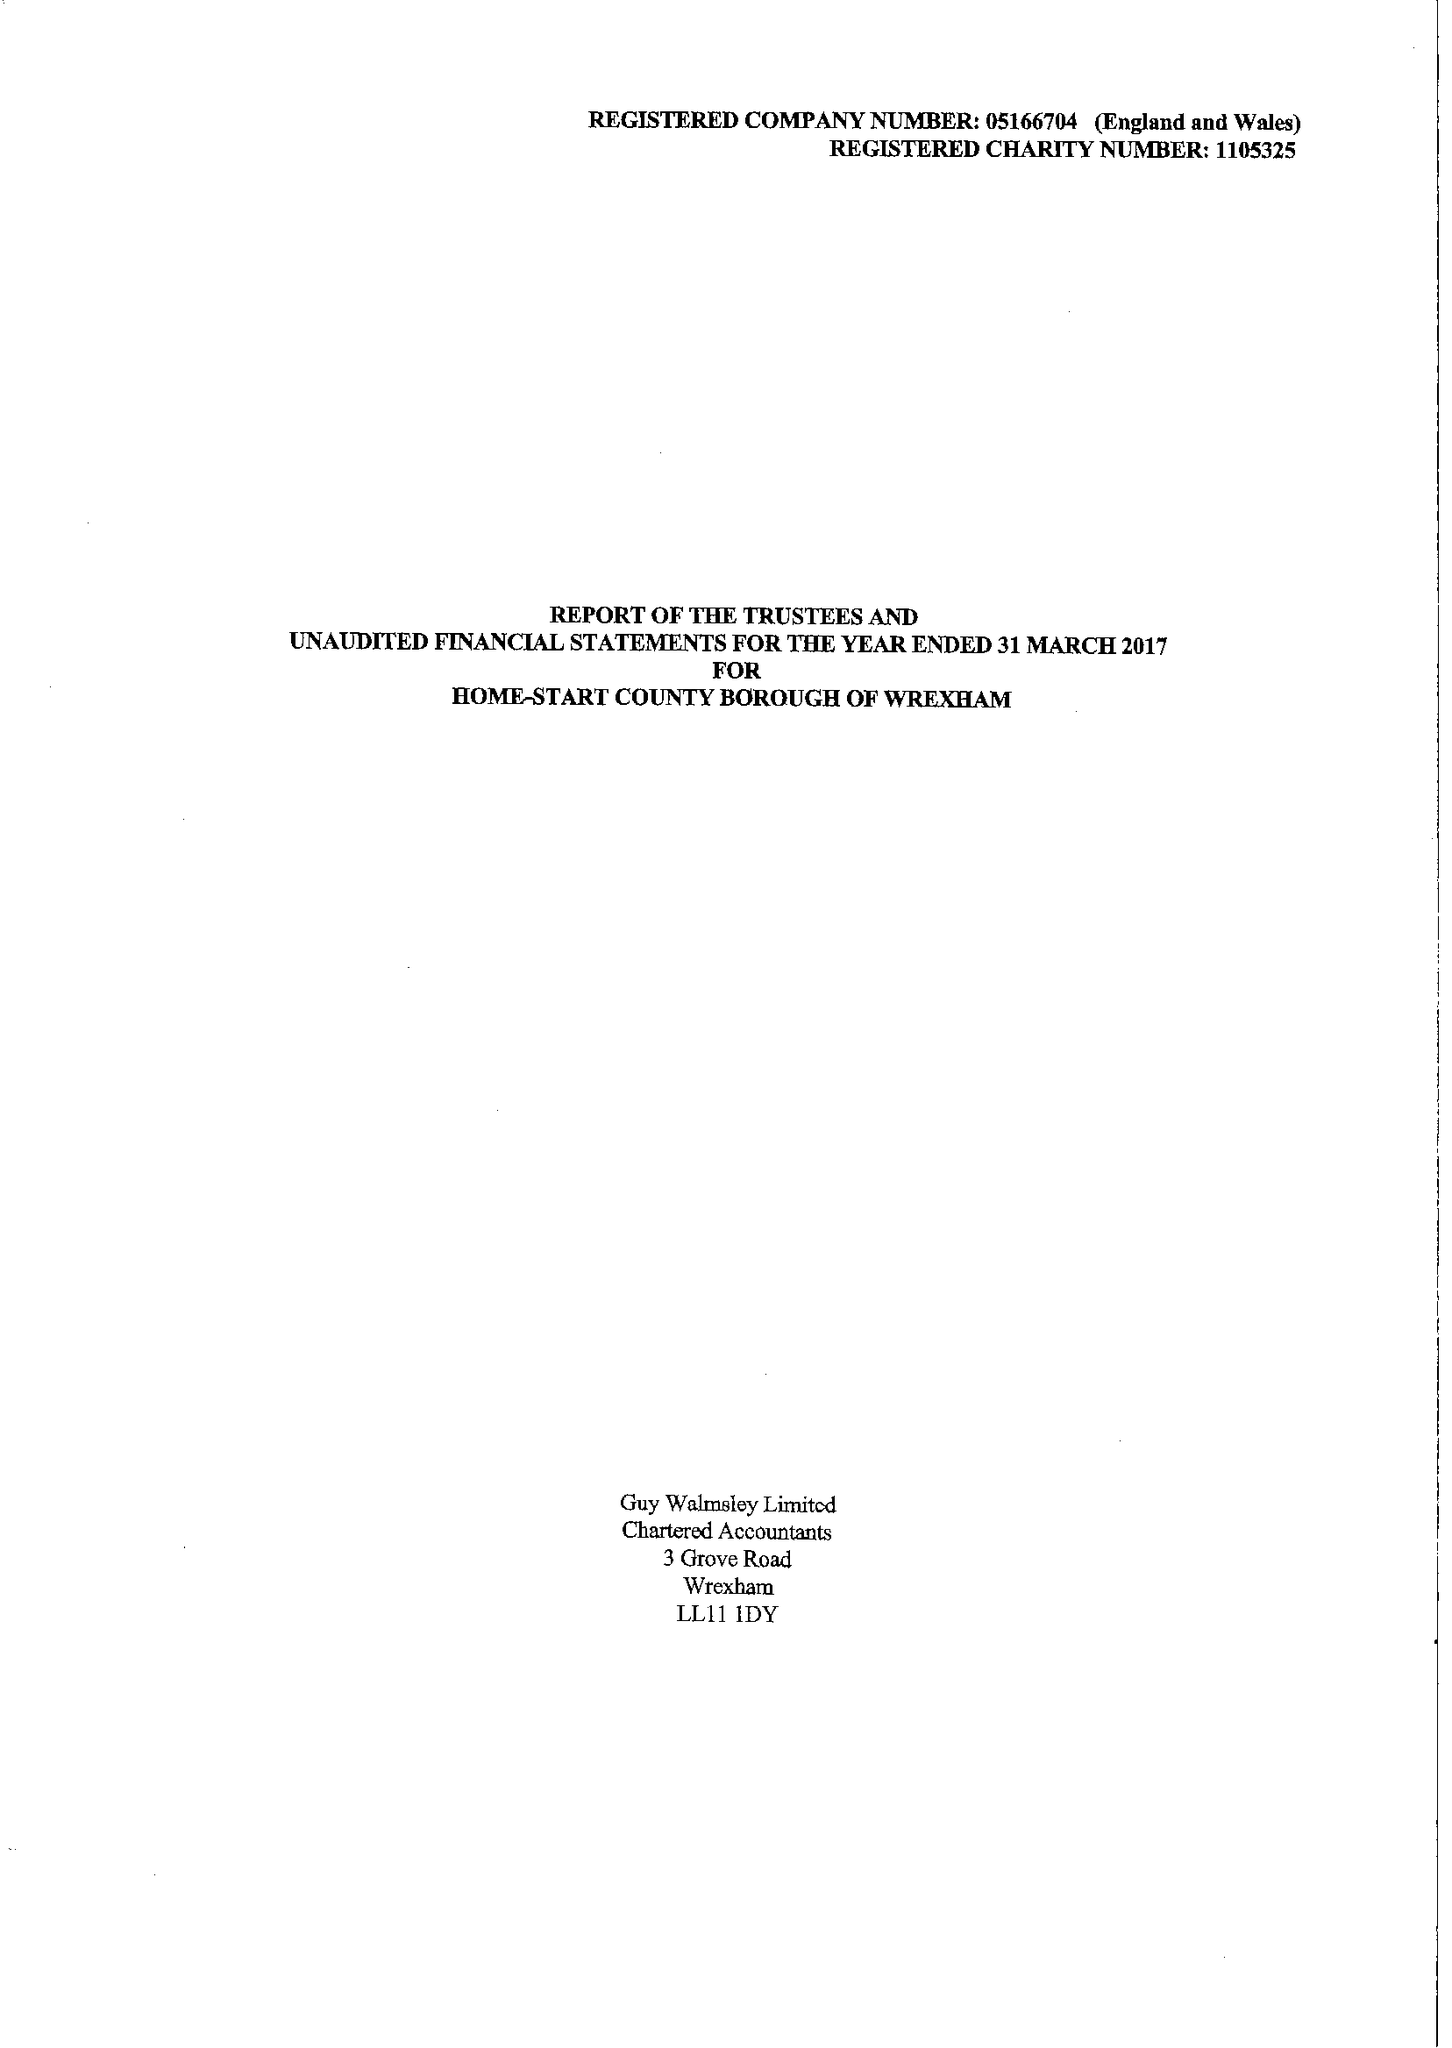What is the value for the charity_number?
Answer the question using a single word or phrase. 1105325 